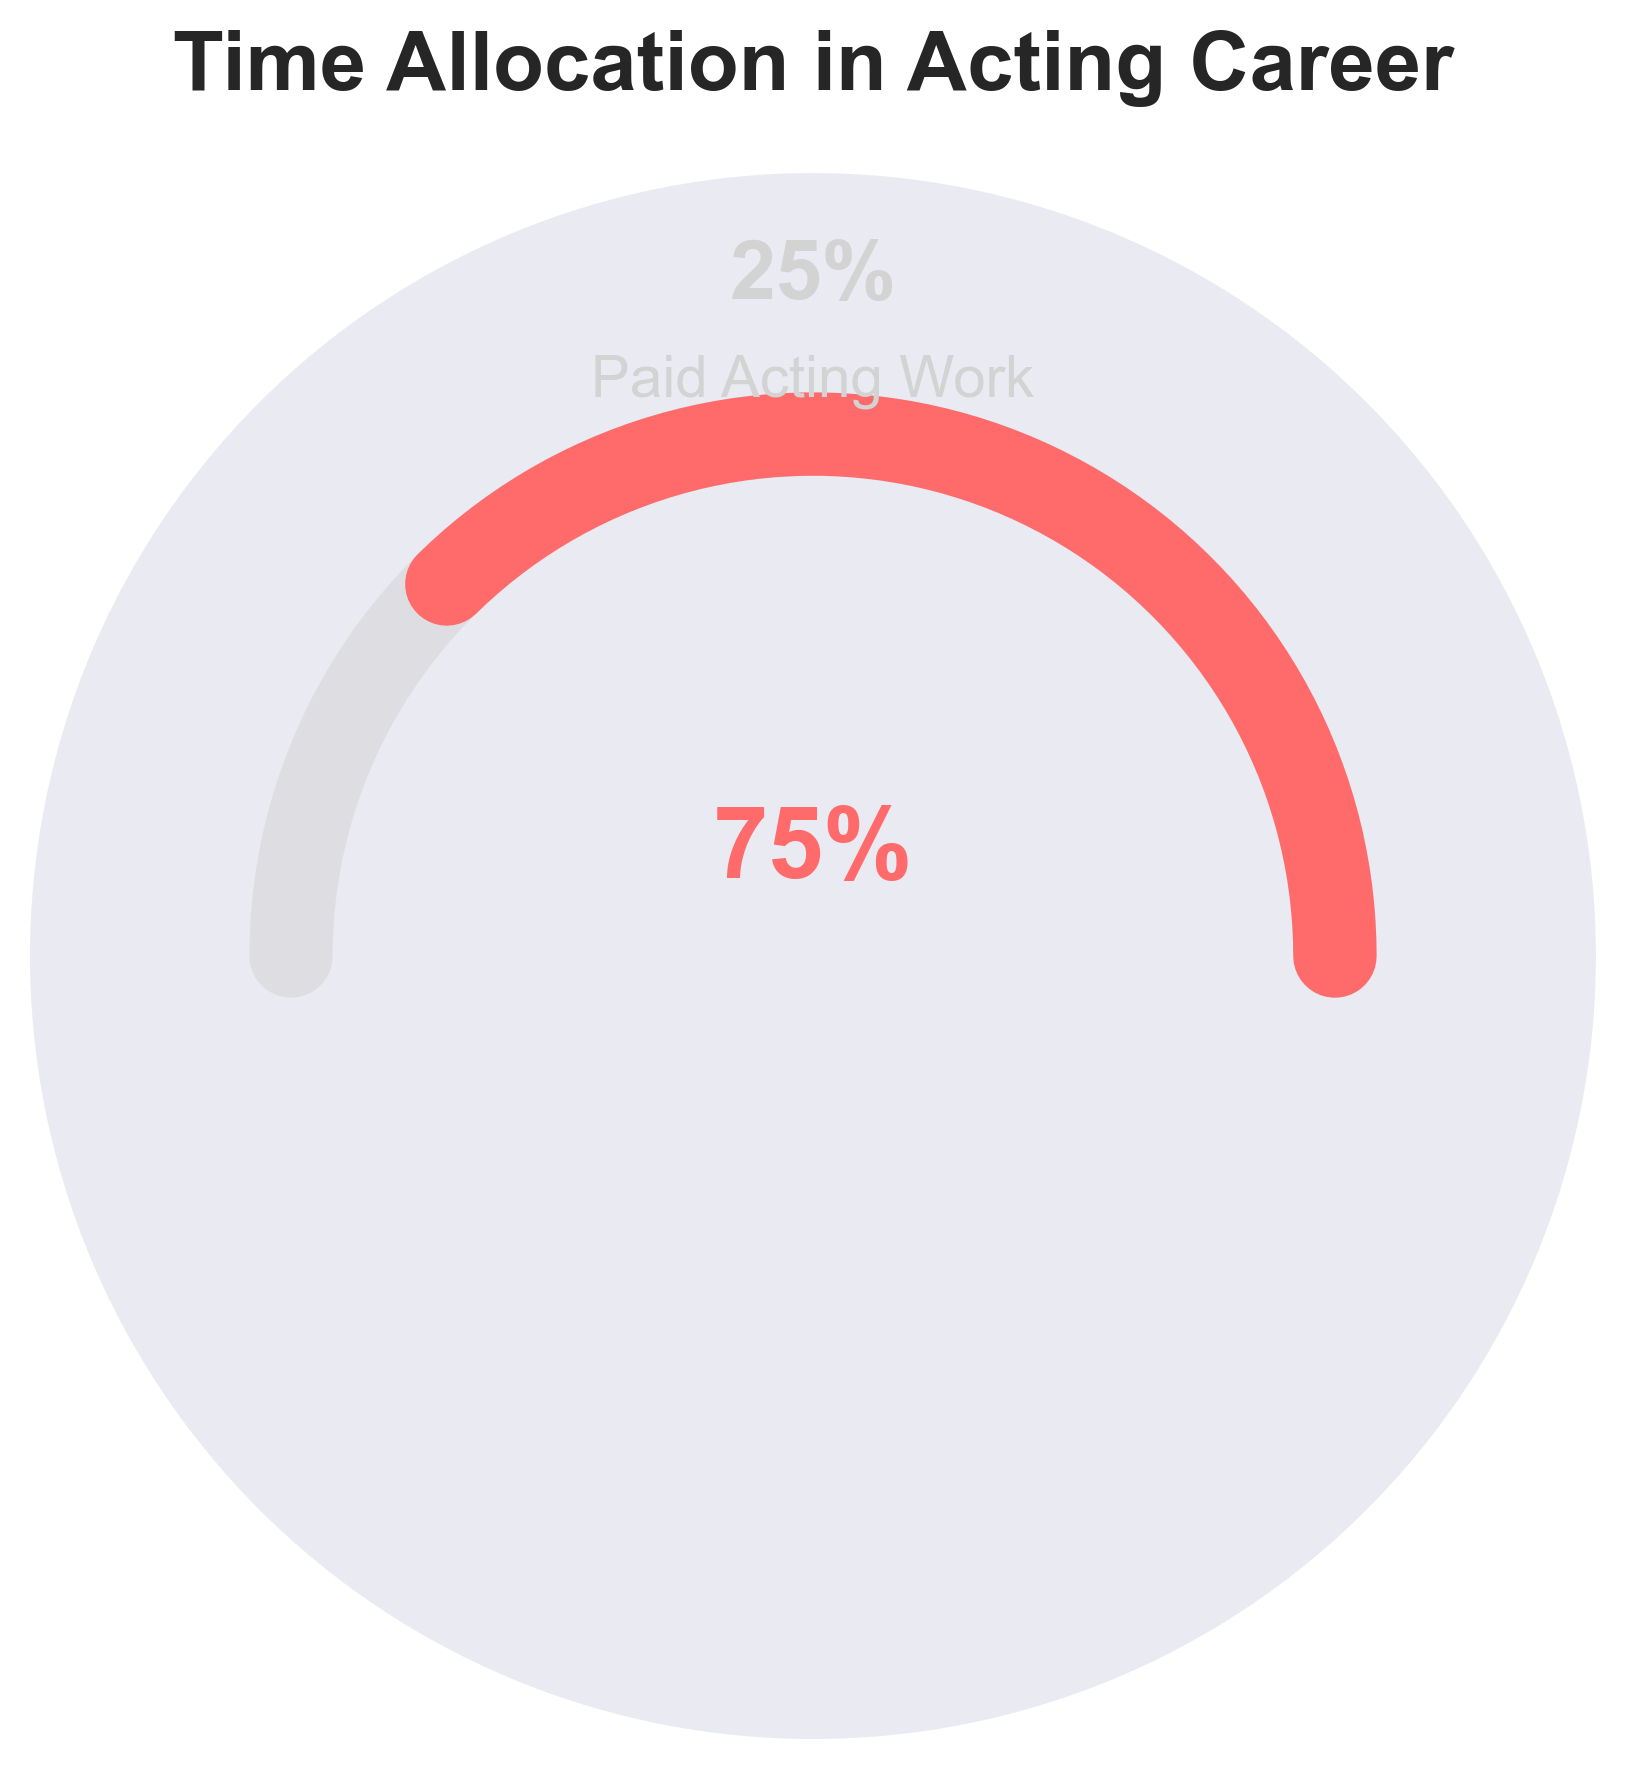What's the percentage of time spent on unpaid acting projects? The figure displays the percentage of time spent on different types of acting projects. The section labeled "Unpaid Acting Projects" indicates 75% of the time allocation.
Answer: 75% What's the percentage of time spent on paid acting work? The figure shows percentages with a clear label for paid acting work. It states 25% for paid acting work.
Answer: 25% Which type of work occupies more time, unpaid acting projects or paid acting work? By comparing the percentages shown in the figure, the unpaid acting projects section covers 75%, while paid acting work covers only 25%.
Answer: Unpaid acting projects How much more time is spent on unpaid acting projects compared to paid acting work? The percentage time spent on unpaid acting projects is 75%, and on paid acting work is 25%. The difference is calculated as 75% - 25%.
Answer: 50% What does the gauge chart title indicate? The title is clearly displayed at the top of the plot and reads "Time Allocation in Acting Career."
Answer: Time Allocation in Acting Career What color represents the unpaid acting projects in the gauge chart? Observing the figure, the portion labeled "Unpaid Acting Projects" is colored in a shade of red.
Answer: Red What is the sum of the percentages of unpaid and paid acting projects? According to the percentages displayed, the unpaid acting projects take 75% and paid acting work takes 25%. The sum of both percentages is 75% + 25%.
Answer: 100% What visual indicator shows that unpaid projects take more time than paid work? The red section on the chart representing unpaid acting projects is significantly larger than the gray section for paid acting work, occupying more than half of the gauge.
Answer: Larger red section Is the statement "Paid acting work takes up to half of the time" accurate based on the chart? By examining the percentages, paid acting work is shown to take up 25% of the time, which is less than half of the total time allocation.
Answer: No How many different categories of time allocation are shown on the gauge chart? The gauge chart visually displays two categories of time allocation: unpaid acting projects and paid acting work.
Answer: Two categories 